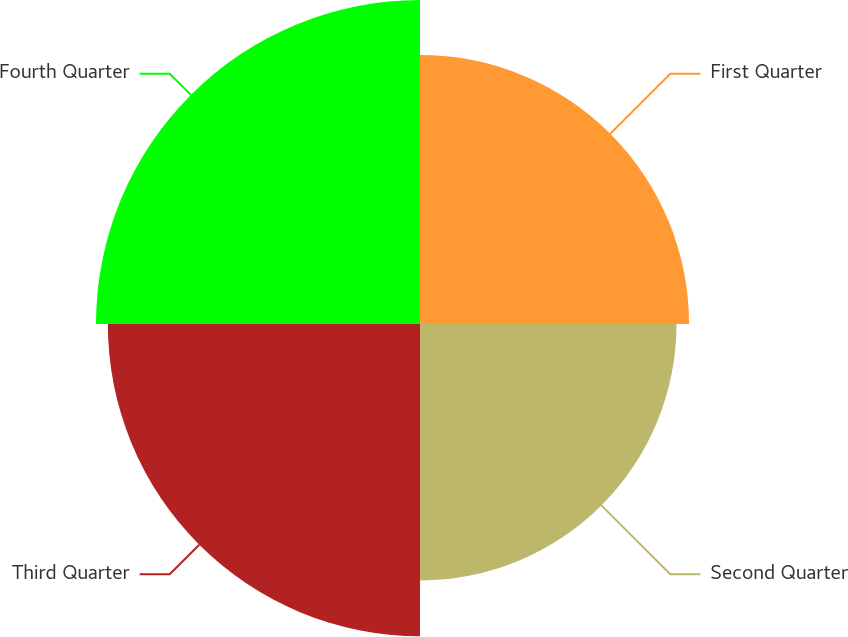<chart> <loc_0><loc_0><loc_500><loc_500><pie_chart><fcel>First Quarter<fcel>Second Quarter<fcel>Third Quarter<fcel>Fourth Quarter<nl><fcel>23.16%<fcel>22.08%<fcel>26.87%<fcel>27.89%<nl></chart> 